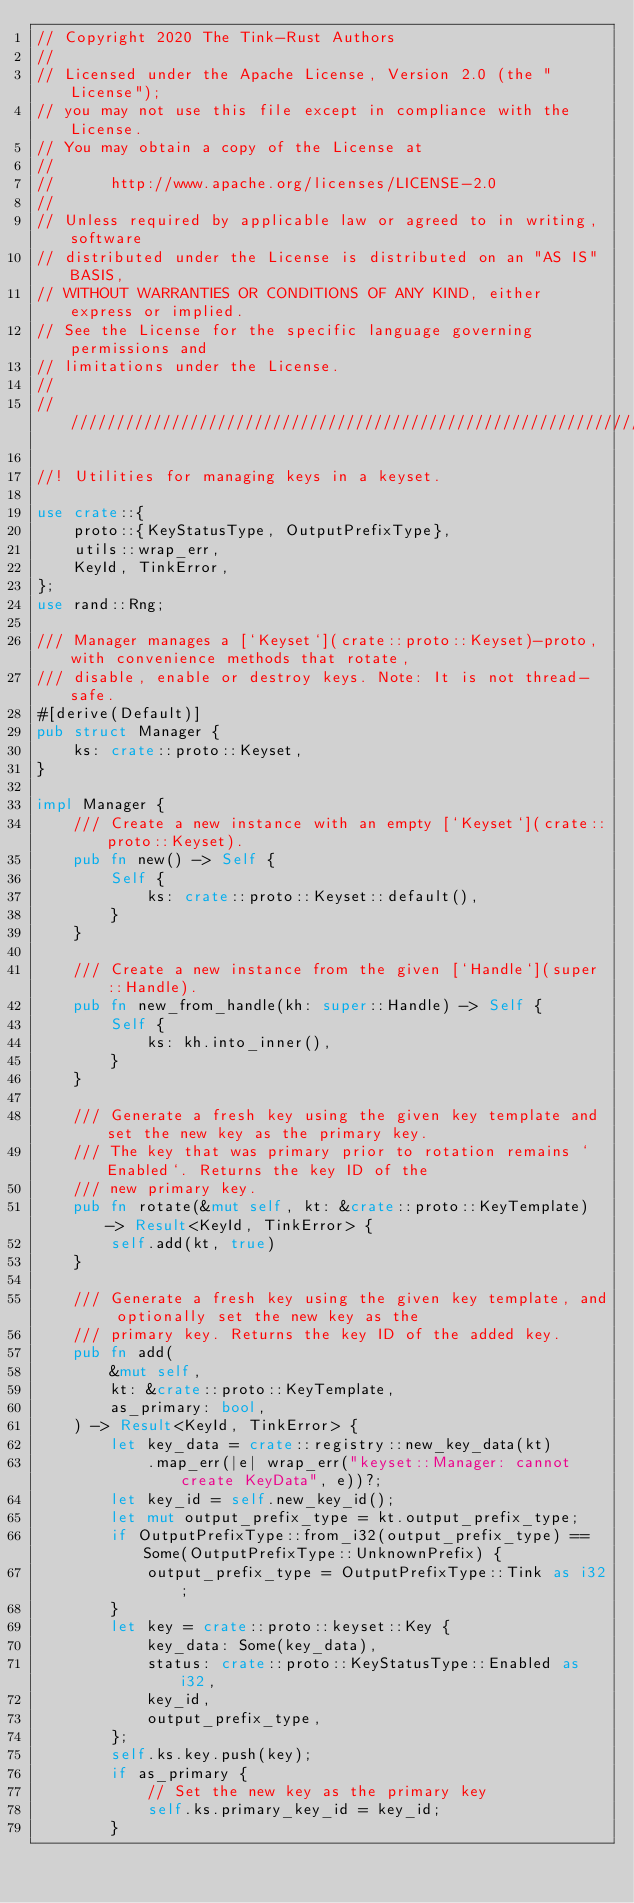<code> <loc_0><loc_0><loc_500><loc_500><_Rust_>// Copyright 2020 The Tink-Rust Authors
//
// Licensed under the Apache License, Version 2.0 (the "License");
// you may not use this file except in compliance with the License.
// You may obtain a copy of the License at
//
//      http://www.apache.org/licenses/LICENSE-2.0
//
// Unless required by applicable law or agreed to in writing, software
// distributed under the License is distributed on an "AS IS" BASIS,
// WITHOUT WARRANTIES OR CONDITIONS OF ANY KIND, either express or implied.
// See the License for the specific language governing permissions and
// limitations under the License.
//
////////////////////////////////////////////////////////////////////////////////

//! Utilities for managing keys in a keyset.

use crate::{
    proto::{KeyStatusType, OutputPrefixType},
    utils::wrap_err,
    KeyId, TinkError,
};
use rand::Rng;

/// Manager manages a [`Keyset`](crate::proto::Keyset)-proto, with convenience methods that rotate,
/// disable, enable or destroy keys. Note: It is not thread-safe.
#[derive(Default)]
pub struct Manager {
    ks: crate::proto::Keyset,
}

impl Manager {
    /// Create a new instance with an empty [`Keyset`](crate::proto::Keyset).
    pub fn new() -> Self {
        Self {
            ks: crate::proto::Keyset::default(),
        }
    }

    /// Create a new instance from the given [`Handle`](super::Handle).
    pub fn new_from_handle(kh: super::Handle) -> Self {
        Self {
            ks: kh.into_inner(),
        }
    }

    /// Generate a fresh key using the given key template and set the new key as the primary key.
    /// The key that was primary prior to rotation remains `Enabled`. Returns the key ID of the
    /// new primary key.
    pub fn rotate(&mut self, kt: &crate::proto::KeyTemplate) -> Result<KeyId, TinkError> {
        self.add(kt, true)
    }

    /// Generate a fresh key using the given key template, and optionally set the new key as the
    /// primary key. Returns the key ID of the added key.
    pub fn add(
        &mut self,
        kt: &crate::proto::KeyTemplate,
        as_primary: bool,
    ) -> Result<KeyId, TinkError> {
        let key_data = crate::registry::new_key_data(kt)
            .map_err(|e| wrap_err("keyset::Manager: cannot create KeyData", e))?;
        let key_id = self.new_key_id();
        let mut output_prefix_type = kt.output_prefix_type;
        if OutputPrefixType::from_i32(output_prefix_type) == Some(OutputPrefixType::UnknownPrefix) {
            output_prefix_type = OutputPrefixType::Tink as i32;
        }
        let key = crate::proto::keyset::Key {
            key_data: Some(key_data),
            status: crate::proto::KeyStatusType::Enabled as i32,
            key_id,
            output_prefix_type,
        };
        self.ks.key.push(key);
        if as_primary {
            // Set the new key as the primary key
            self.ks.primary_key_id = key_id;
        }</code> 